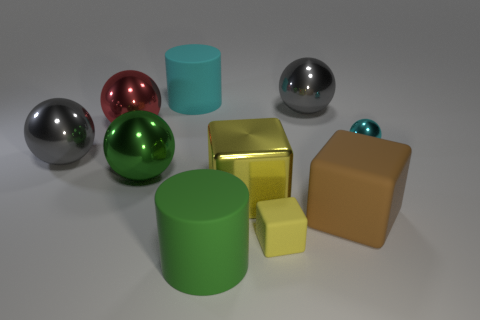How many other things are made of the same material as the large green sphere? Analyzing the image, it appears there are a total of five objects that have a similar reflective surface, indicating they could be made of the same or similar material as the large green sphere. 